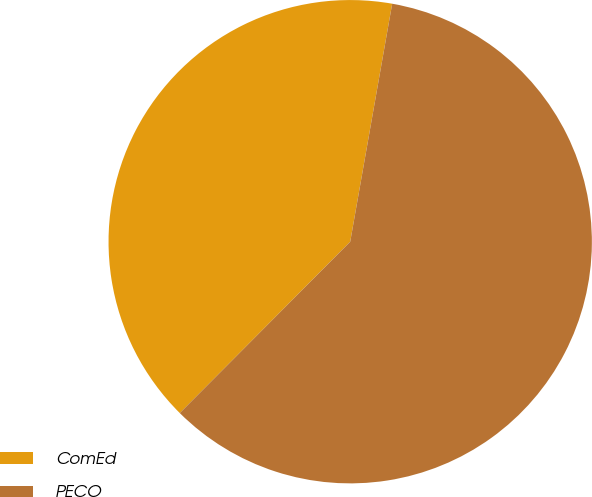<chart> <loc_0><loc_0><loc_500><loc_500><pie_chart><fcel>ComEd<fcel>PECO<nl><fcel>40.32%<fcel>59.68%<nl></chart> 